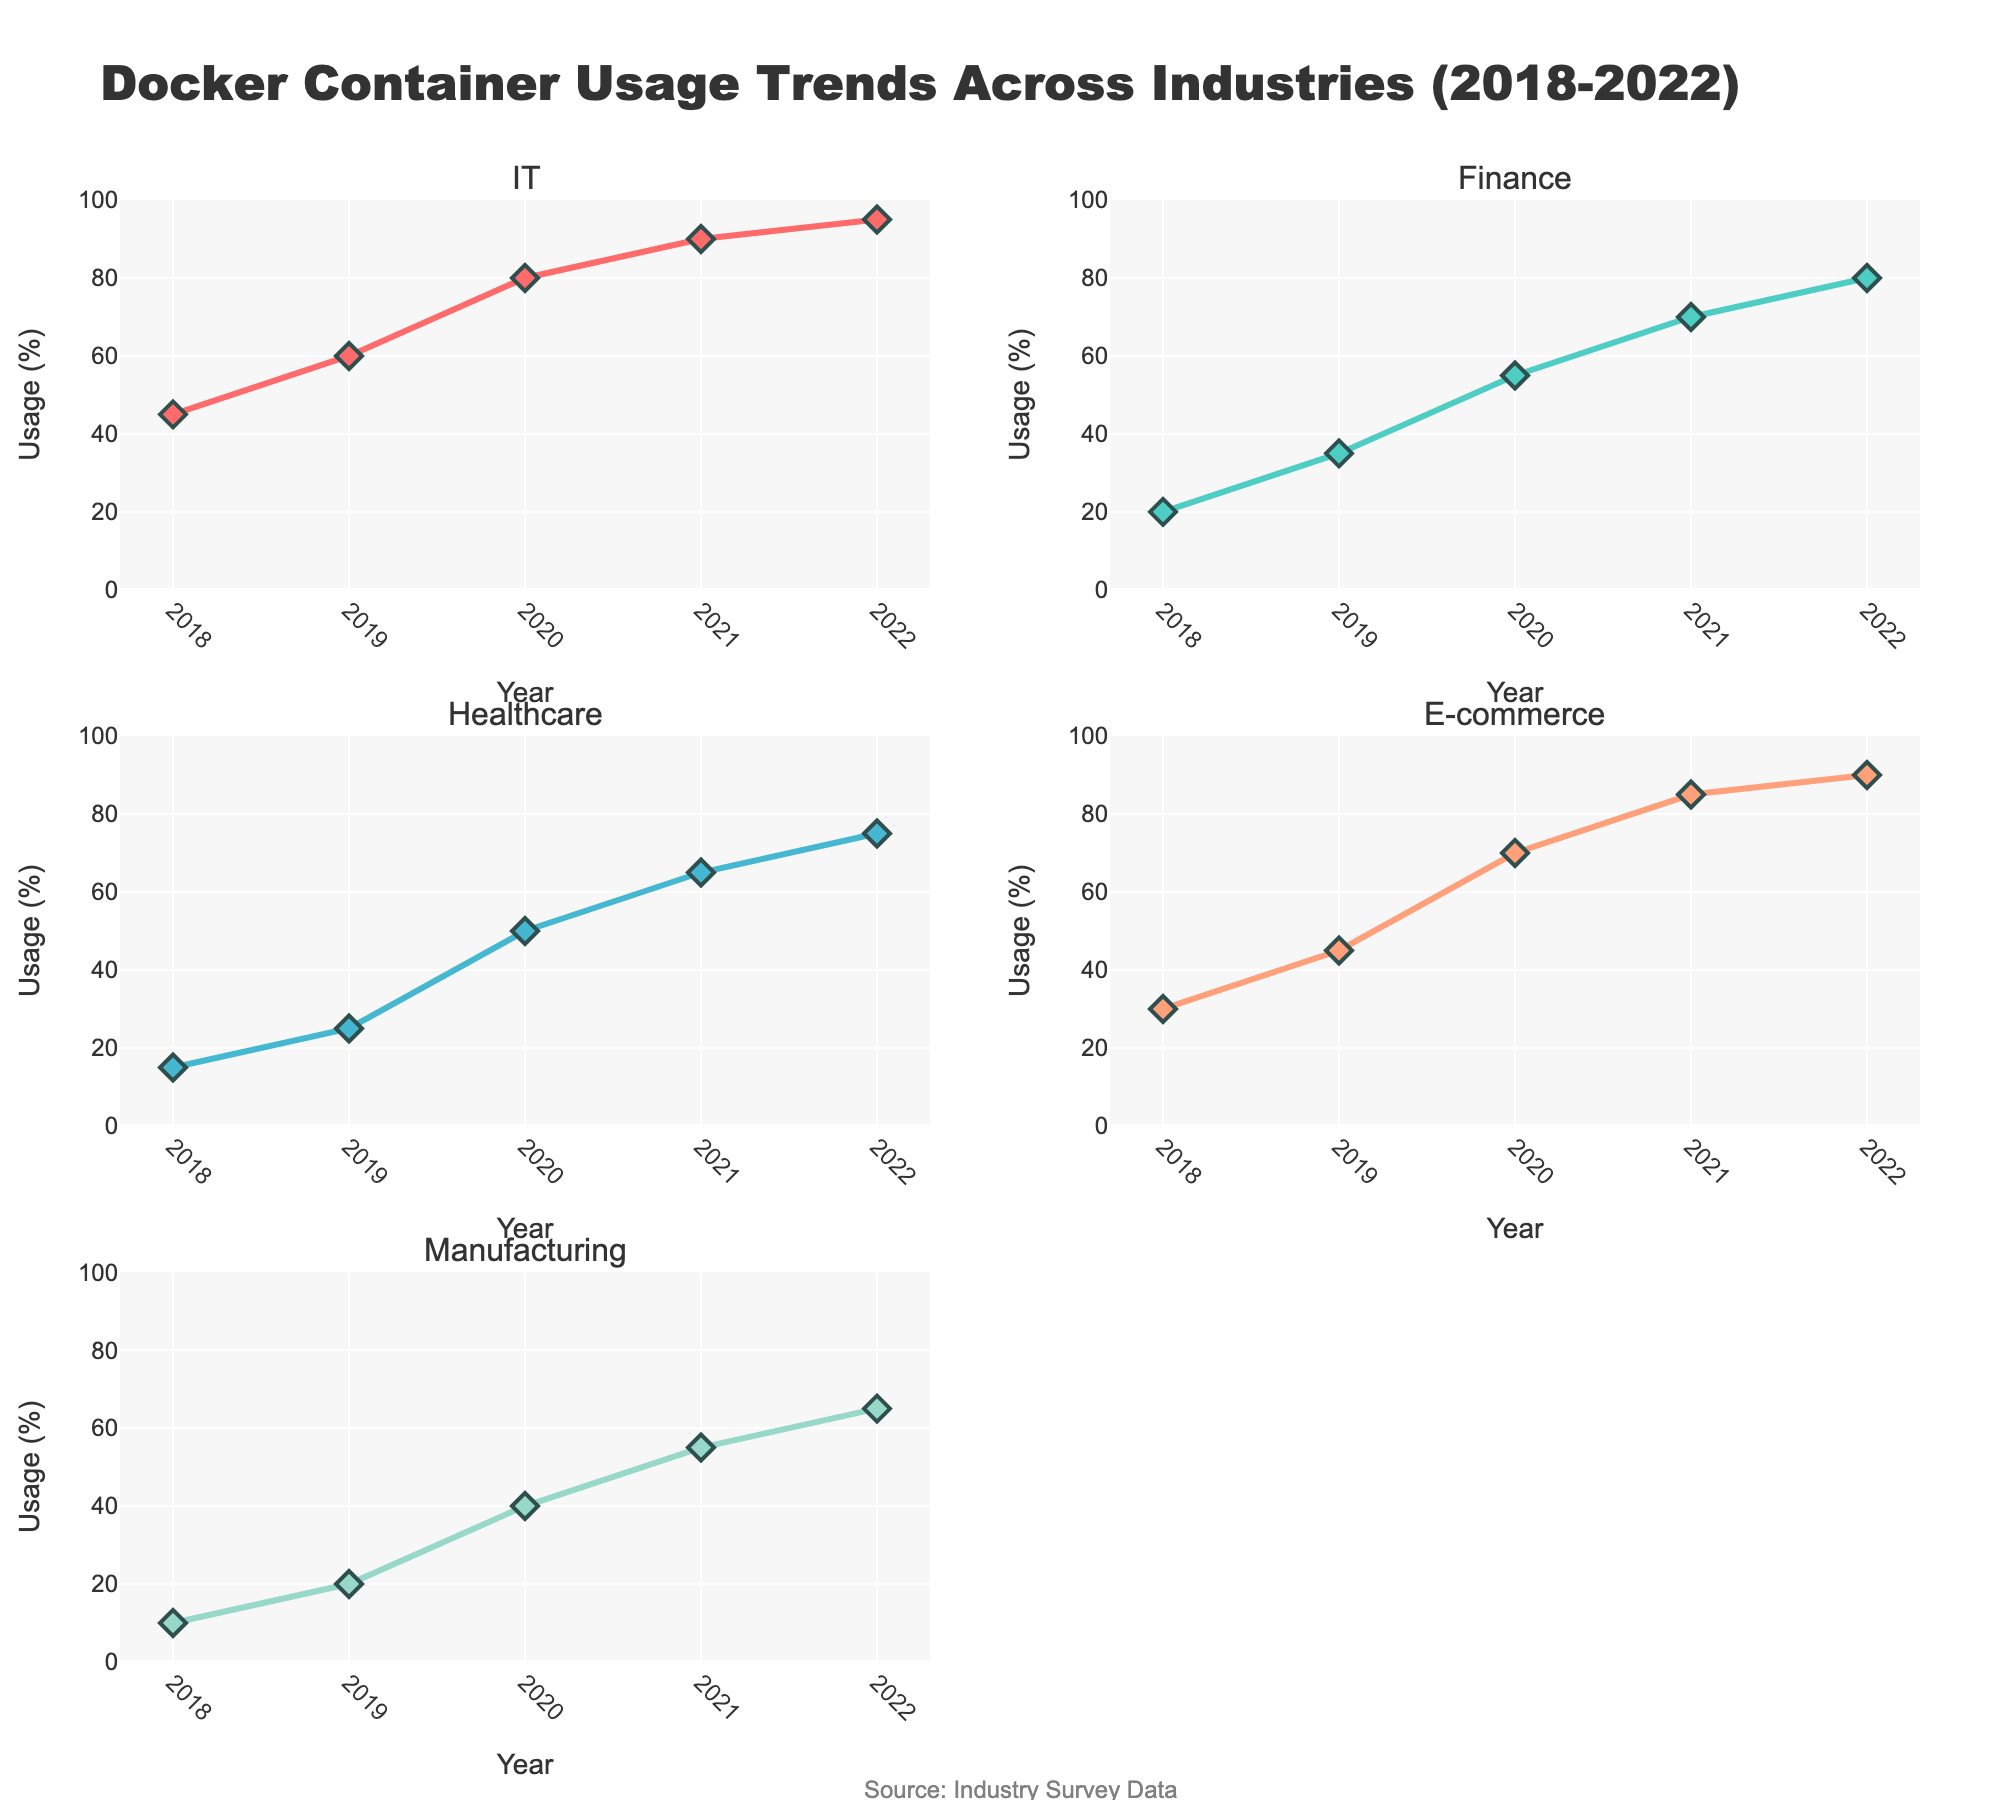What is the title of the figure? The title of the figure is prominently displayed at the top of the chart above all subplots. It specifically mentions Docker Container Usage Trends and the time frame of the data.
Answer: Docker Container Usage Trends Across Industries (2018-2022) How many subplots are included in the figure? The figure uses a 3x2 layout for subplots as described, with one subplot for each industry. By counting, we find a total of 5 subplots for IT, Finance, Healthcare, E-commerce, and Manufacturing.
Answer: 5 What's the general trend in Docker container usage for the IT industry from 2018 to 2022? By following the IT industry's line chart in its respective subplot, we observe a steady increase from 45% in 2018 to 95% in 2022. This indicates a clear upward trend.
Answer: Increasing Which industry showed the highest increase in Docker usage from 2018 to 2022? Comparing the final usage percentages of all industries and their initial values in the respective subplots, we find the IT industry increased from 45% to 95%, which is the highest increase.
Answer: IT Between which years did the Healthcare industry see the most significant increase in Docker usage? Healthcare usage data in the subplot shows 15% in 2018, 25% in 2019, 50% in 2020, 65% in 2021, and 75% in 2022. The largest increase happens between 2019 and 2020, with a jump of 25%.
Answer: 2019 to 2020 What is the average Docker usage for the Finance industry over the five-year period? The Finance usage data points are 20, 35, 55, 70, and 80. Adding these up gives 260. Dividing by 5 years gives us an average of 52%.
Answer: 52% Which industries have a usage percentage above 60% by 2022? Referring to the end values in each subplot, IT (95%), Finance (80%), Healthcare (75%), E-commerce (90%), and Manufacturing (65%) all have usage above 60%.
Answer: IT, Finance, Healthcare, E-commerce, Manufacturing For which years did E-commerce have a higher percentage of Docker usage than Manufacturing? By comparing each year's values for E-commerce and Manufacturing subplots: 2018 (30 vs. 10), 2019 (45 vs. 20), 2020 (70 vs. 40), 2021 (85 vs. 55), 2022 (90 vs. 65). E-commerce usage was higher in all 5 years.
Answer: 2018, 2019, 2020, 2021, 2022 Which industry had the smallest absolute increase in Docker usage from 2020 to 2021? From 2020 to 2021: IT (80 to 90 = 10), Finance (55 to 70 = 15), Healthcare (50 to 65 = 15), E-commerce (70 to 85 = 15), Manufacturing (40 to 55 = 15). IT had the smallest increase with an absolute change of 10%.
Answer: IT 